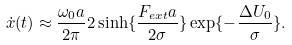<formula> <loc_0><loc_0><loc_500><loc_500>\dot { x } ( t ) \approx \frac { \omega _ { 0 } a } { 2 \pi } 2 \sinh \{ \frac { F _ { e x t } a } { 2 \sigma } \} \exp \{ - \frac { \Delta U _ { 0 } } { \sigma } \} .</formula> 